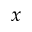<formula> <loc_0><loc_0><loc_500><loc_500>x</formula> 